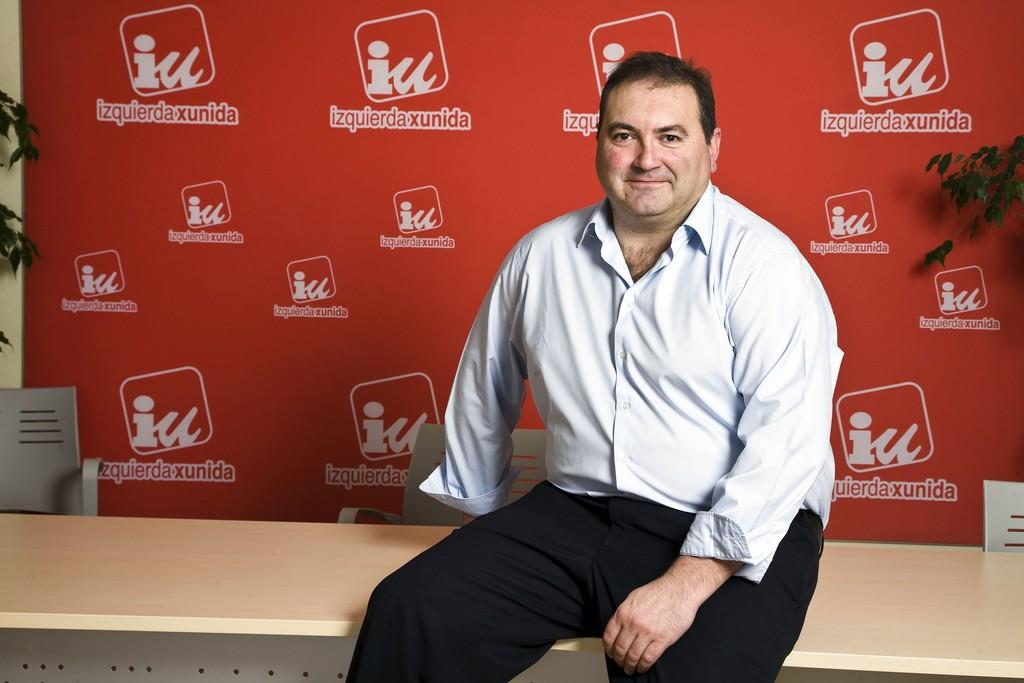What is the man in the image doing? The man is sitting on a table in the image. What can be seen in the background of the image? There are chairs, a board, a wall, and plants in the background of the image. What type of apple is being used as a place to hold the bun in the image? There is no apple or bun present in the image. 